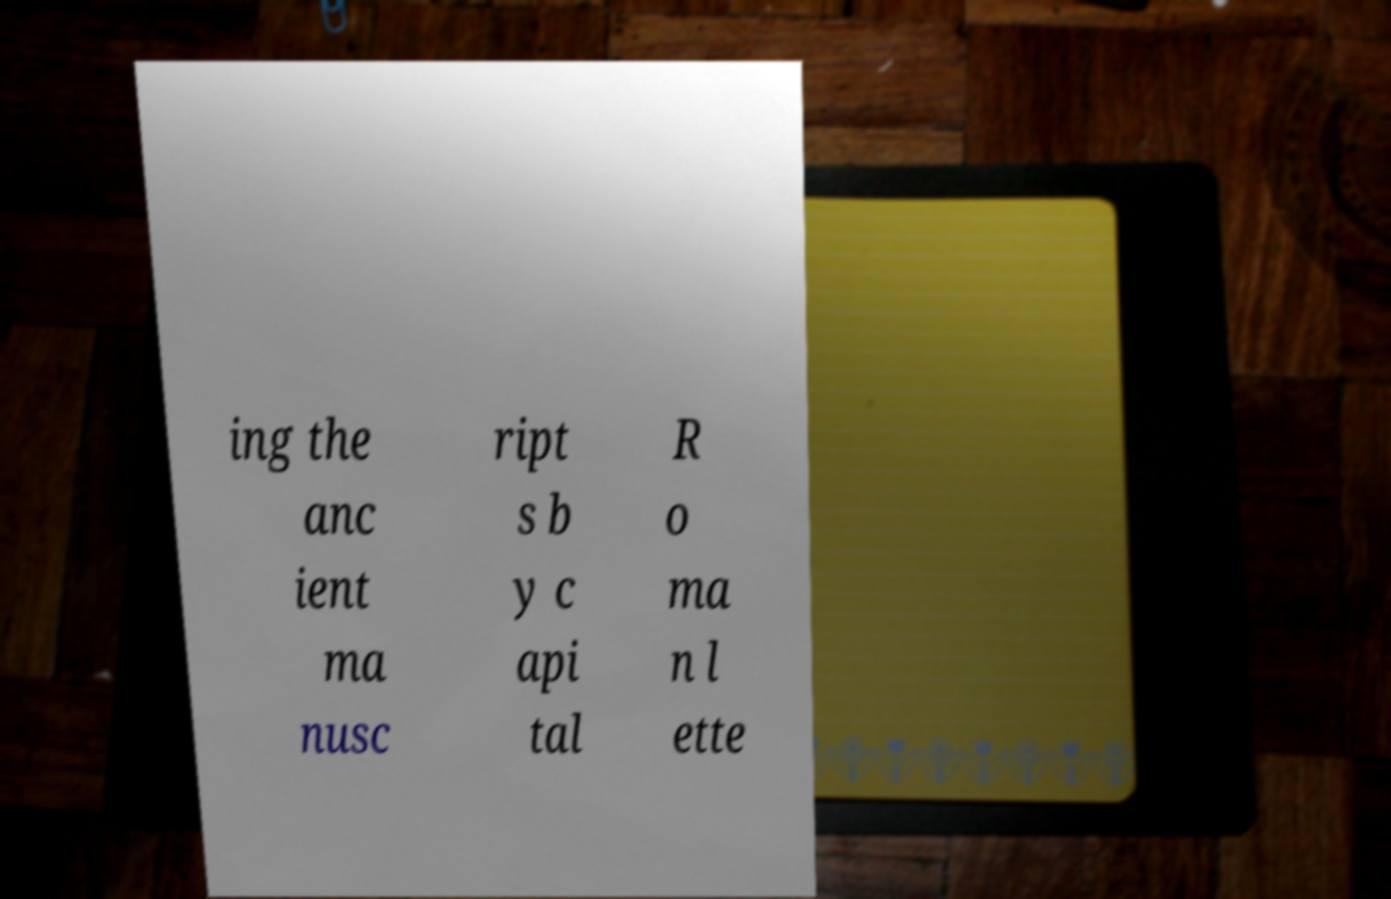What messages or text are displayed in this image? I need them in a readable, typed format. ing the anc ient ma nusc ript s b y c api tal R o ma n l ette 